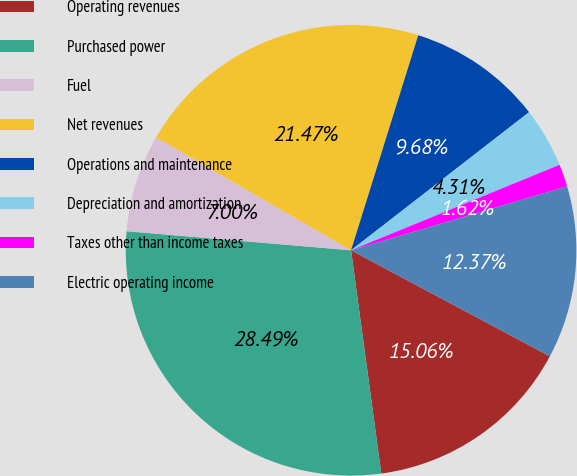<chart> <loc_0><loc_0><loc_500><loc_500><pie_chart><fcel>Operating revenues<fcel>Purchased power<fcel>Fuel<fcel>Net revenues<fcel>Operations and maintenance<fcel>Depreciation and amortization<fcel>Taxes other than income taxes<fcel>Electric operating income<nl><fcel>15.06%<fcel>28.49%<fcel>7.0%<fcel>21.47%<fcel>9.68%<fcel>4.31%<fcel>1.62%<fcel>12.37%<nl></chart> 